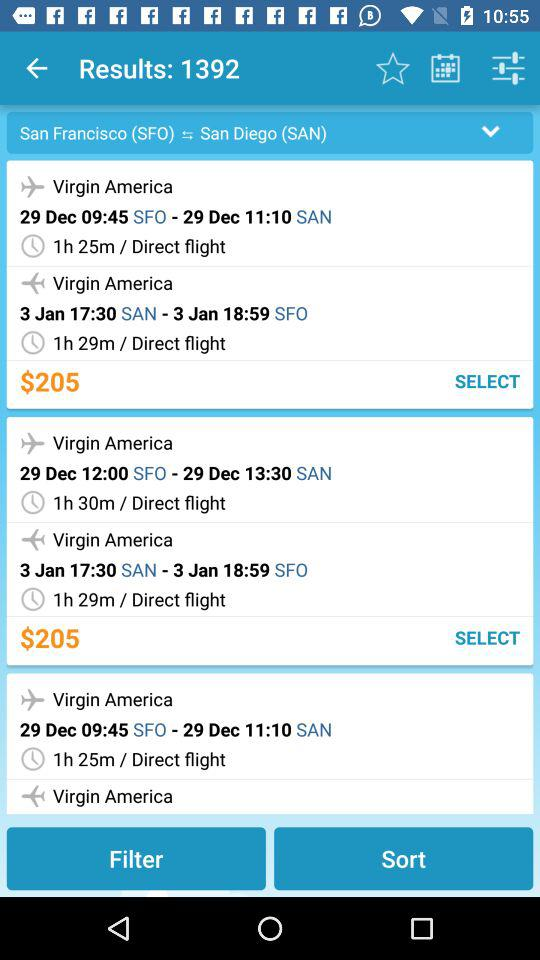How many results are shown there? There are 1392 results shown. 